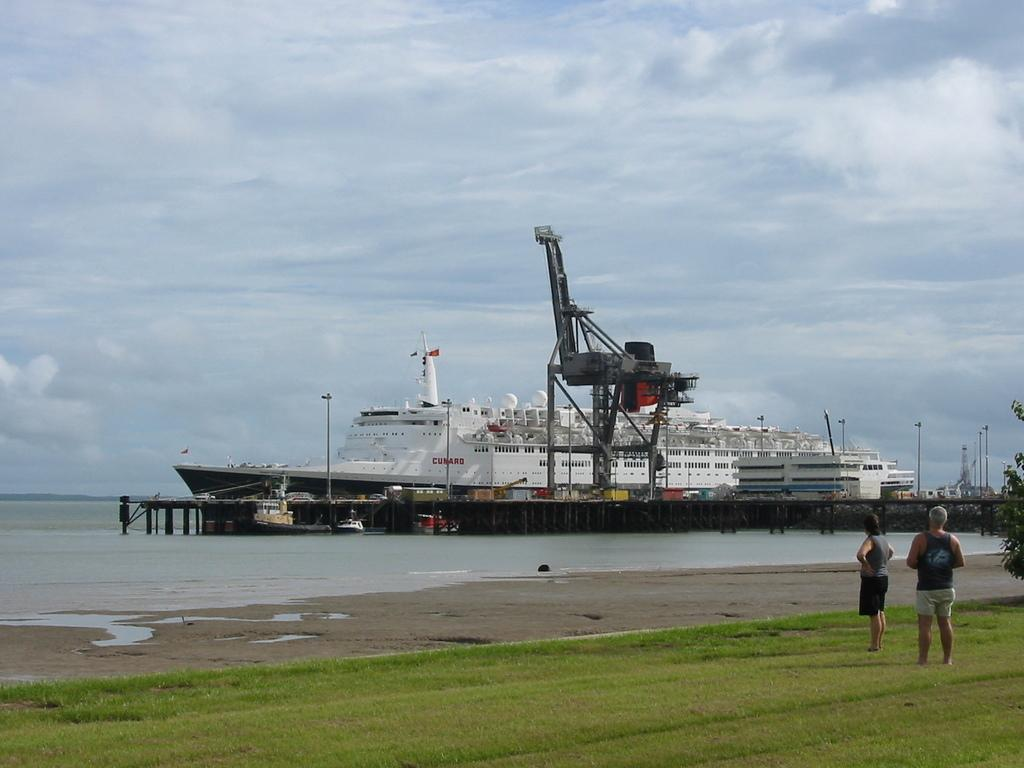How many people are present in the image? There are two people standing on the ground in the image. What is located on the water in the image? There is a ship on the water in the image. What can be seen in the background of the image? Clouds and the sky are visible in the background of the image. What type of insurance does the sister of the person in the image have? There is no mention of a sister or insurance in the image, so this information cannot be determined. 